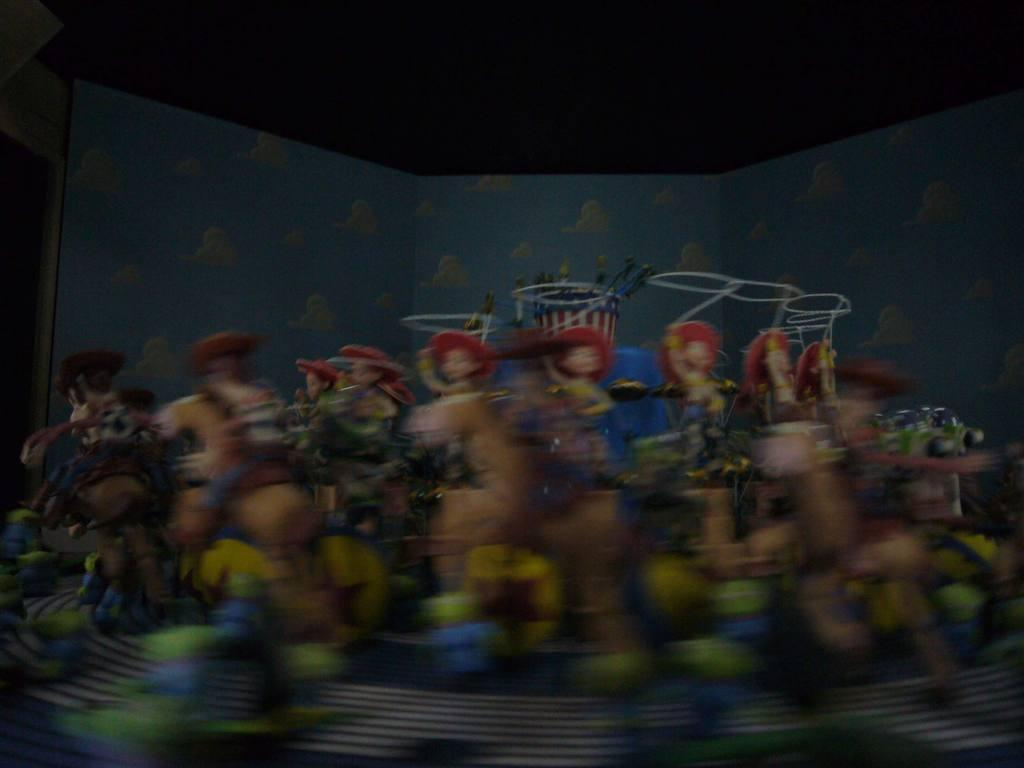What objects are present in the image? There are toys in the image. What colors can be seen in the background of the image? The background of the image has blue and black colors. How would you describe the clarity of the image? The image is blurred. Where is the board located in the image? There is no board present in the image. What type of basin can be seen in the image? There is no basin present in the image. 